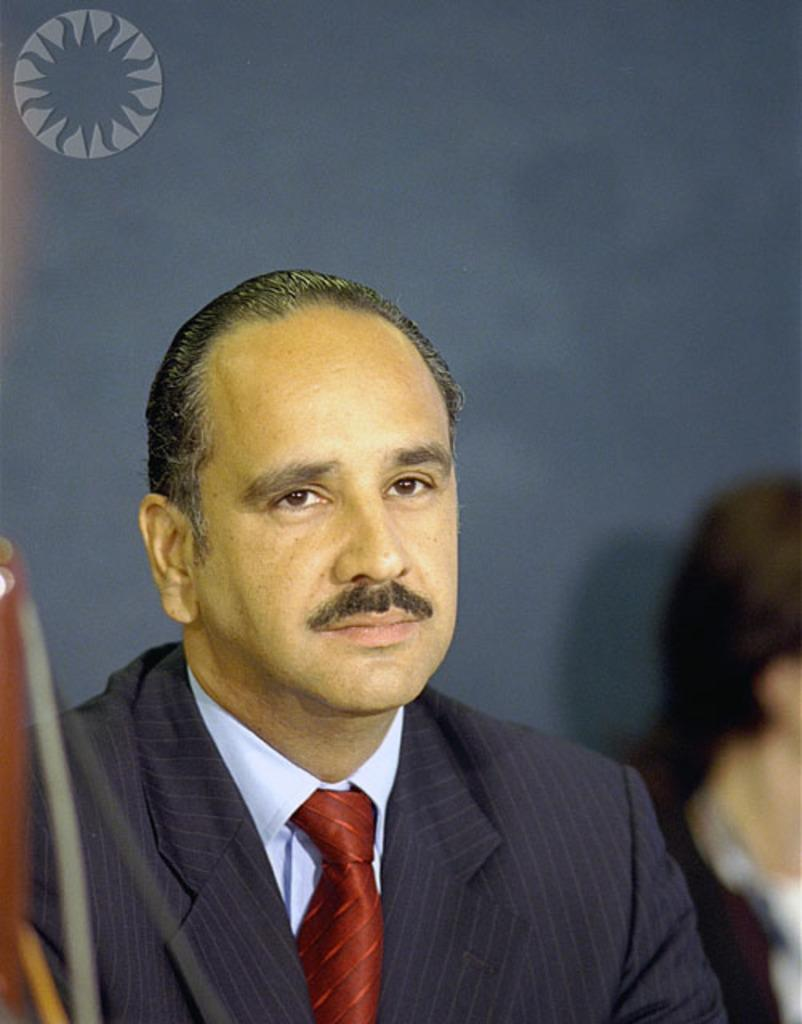Who is present in the image? There is a man in the image. What is the man wearing? The man is wearing a blazer. Can you describe the background of the image? The background of the image is blurred. Is there any additional information or markings on the image? Yes, there is a watermark on the image. What verse can be seen written on the man's blazer in the image? There is no verse written on the man's blazer in the image. Can you describe the man taking a bite out of something in the image? There is no indication of the man taking a bite out of anything in the image. 